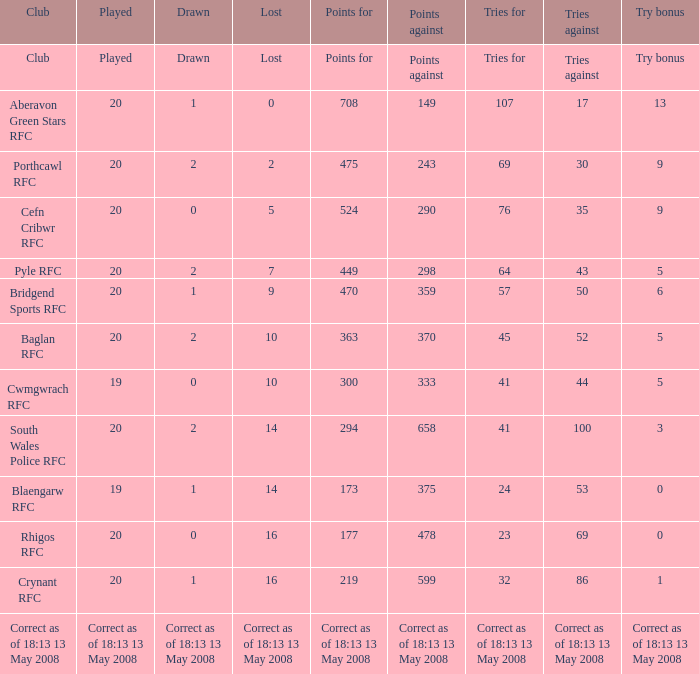What is the trials against when the points reach 475? 30.0. 